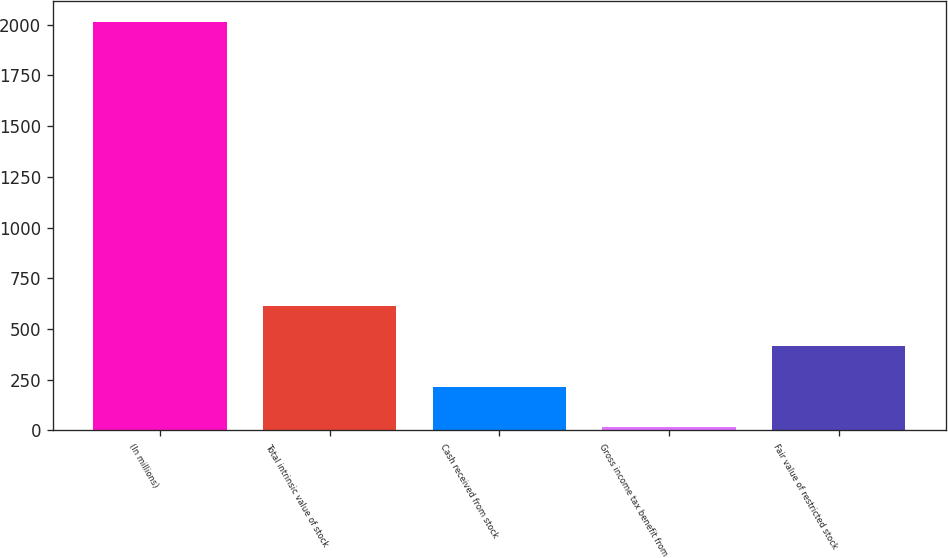<chart> <loc_0><loc_0><loc_500><loc_500><bar_chart><fcel>(In millions)<fcel>Total intrinsic value of stock<fcel>Cash received from stock<fcel>Gross income tax benefit from<fcel>Fair value of restricted stock<nl><fcel>2014<fcel>615.4<fcel>215.8<fcel>16<fcel>415.6<nl></chart> 